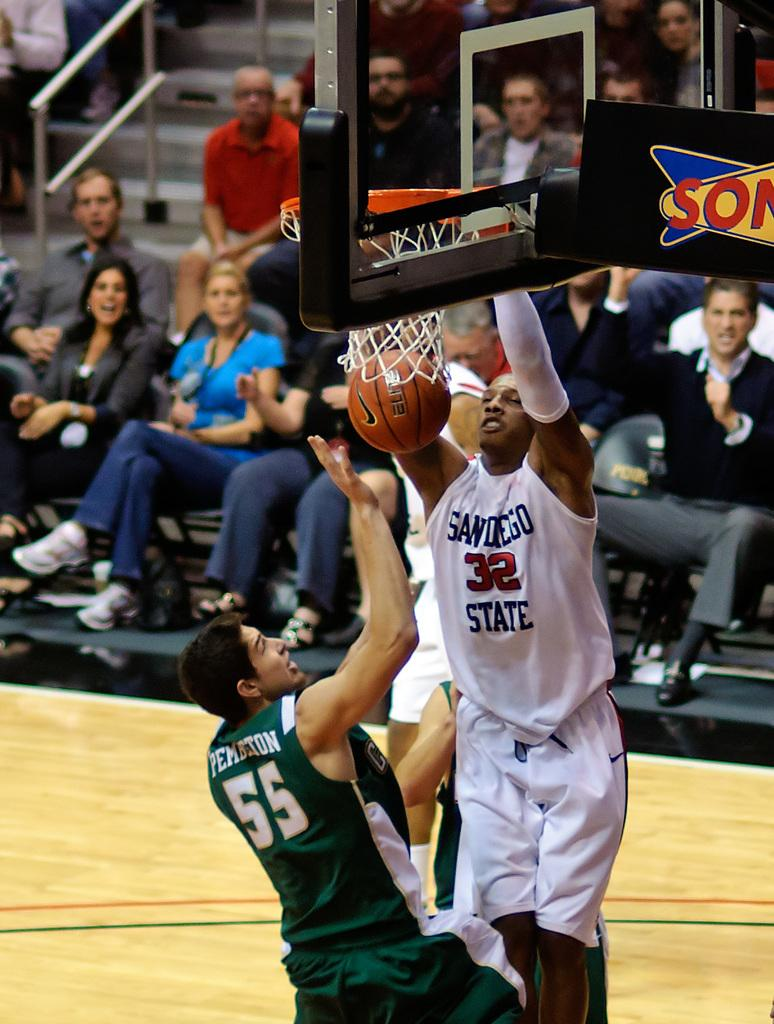What are the two people in the image doing? The two people in the image are jumping. What can be seen at the top of the image? There is a basketball hoop at the top of the image. What object is visible in the image that is related to the basketball hoop? There is a basketball visible in the image. What is happening in the background of the image? There are people sitting in the background of the image. What type of chicken can be seen jumping with the people in the image? There is no chicken present in the image; it features two people jumping near a basketball hoop. Can you tell me how many crackers are visible in the image? There are no crackers present in the image. 